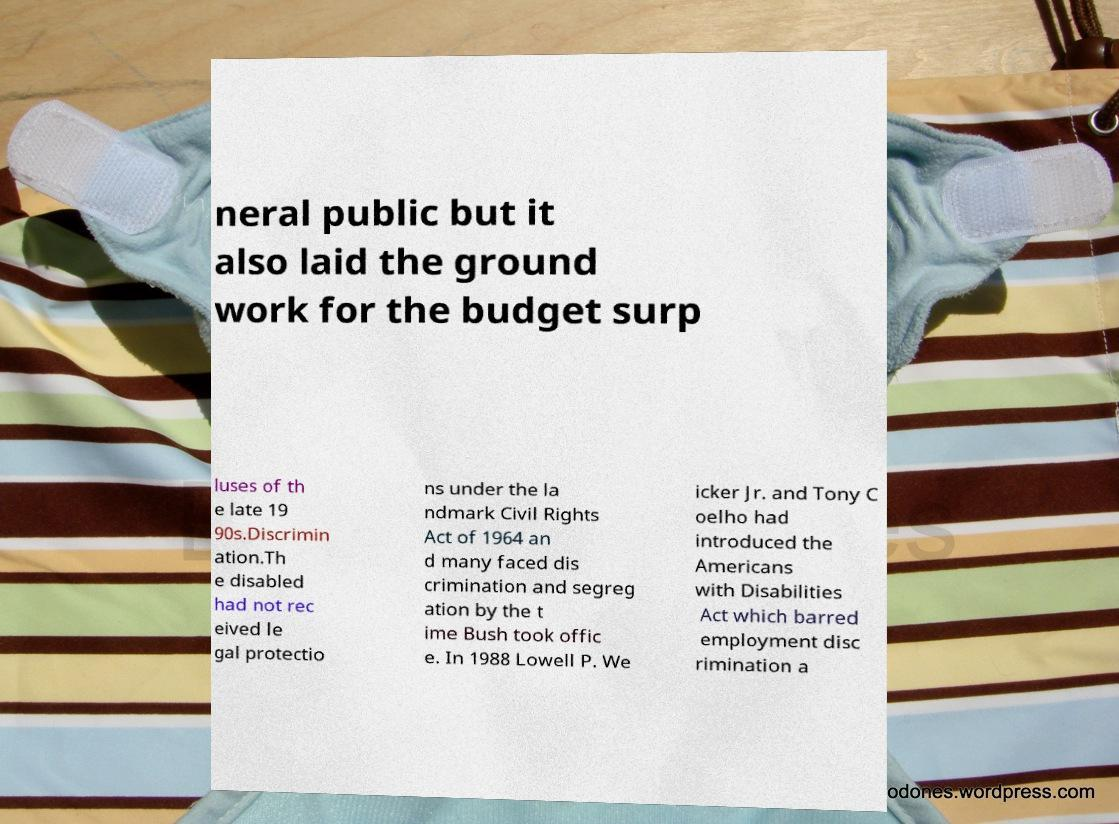For documentation purposes, I need the text within this image transcribed. Could you provide that? neral public but it also laid the ground work for the budget surp luses of th e late 19 90s.Discrimin ation.Th e disabled had not rec eived le gal protectio ns under the la ndmark Civil Rights Act of 1964 an d many faced dis crimination and segreg ation by the t ime Bush took offic e. In 1988 Lowell P. We icker Jr. and Tony C oelho had introduced the Americans with Disabilities Act which barred employment disc rimination a 